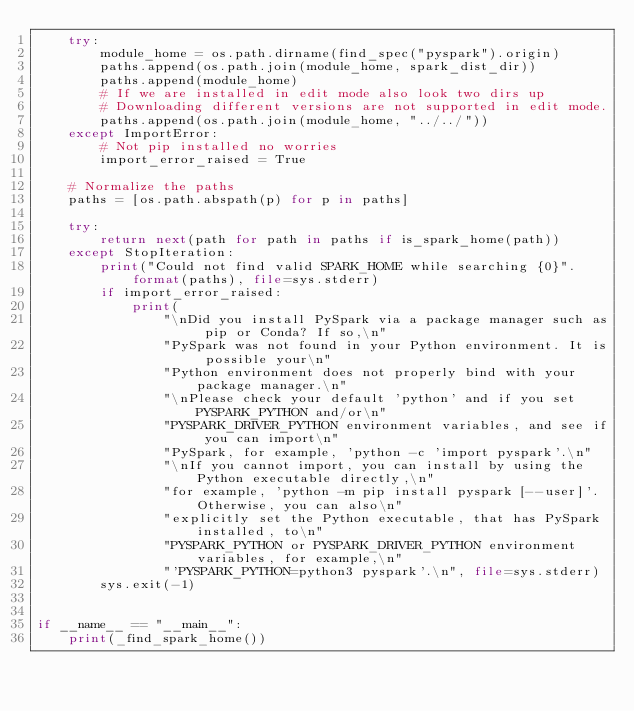Convert code to text. <code><loc_0><loc_0><loc_500><loc_500><_Python_>    try:
        module_home = os.path.dirname(find_spec("pyspark").origin)
        paths.append(os.path.join(module_home, spark_dist_dir))
        paths.append(module_home)
        # If we are installed in edit mode also look two dirs up
        # Downloading different versions are not supported in edit mode.
        paths.append(os.path.join(module_home, "../../"))
    except ImportError:
        # Not pip installed no worries
        import_error_raised = True

    # Normalize the paths
    paths = [os.path.abspath(p) for p in paths]

    try:
        return next(path for path in paths if is_spark_home(path))
    except StopIteration:
        print("Could not find valid SPARK_HOME while searching {0}".format(paths), file=sys.stderr)
        if import_error_raised:
            print(
                "\nDid you install PySpark via a package manager such as pip or Conda? If so,\n"
                "PySpark was not found in your Python environment. It is possible your\n"
                "Python environment does not properly bind with your package manager.\n"
                "\nPlease check your default 'python' and if you set PYSPARK_PYTHON and/or\n"
                "PYSPARK_DRIVER_PYTHON environment variables, and see if you can import\n"
                "PySpark, for example, 'python -c 'import pyspark'.\n"
                "\nIf you cannot import, you can install by using the Python executable directly,\n"
                "for example, 'python -m pip install pyspark [--user]'. Otherwise, you can also\n"
                "explicitly set the Python executable, that has PySpark installed, to\n"
                "PYSPARK_PYTHON or PYSPARK_DRIVER_PYTHON environment variables, for example,\n"
                "'PYSPARK_PYTHON=python3 pyspark'.\n", file=sys.stderr)
        sys.exit(-1)


if __name__ == "__main__":
    print(_find_spark_home())
</code> 